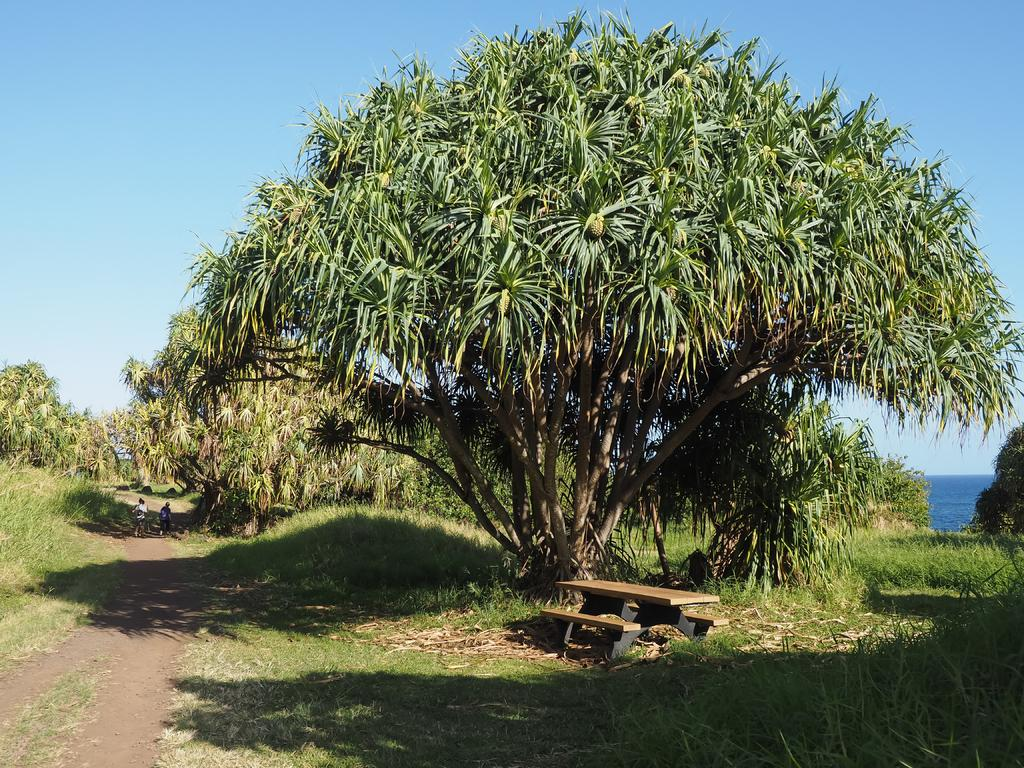What type of surface can be seen in the image? Ground is visible in the image. What feature is present for walking or traversing the area? There is a path in the image. What type of vegetation is present in the image? There is grass and plants in the image. What type of seating is available in the image? There are benches in the image. What natural element can be seen in the image? Water is visible in the image. What part of the environment is visible in the image? The sky is visible in the image. Who is the owner of the mask seen in the image? There is no mask present in the image. What type of bead is used to decorate the plants in the image? There are no beads used to decorate the plants in the image. 